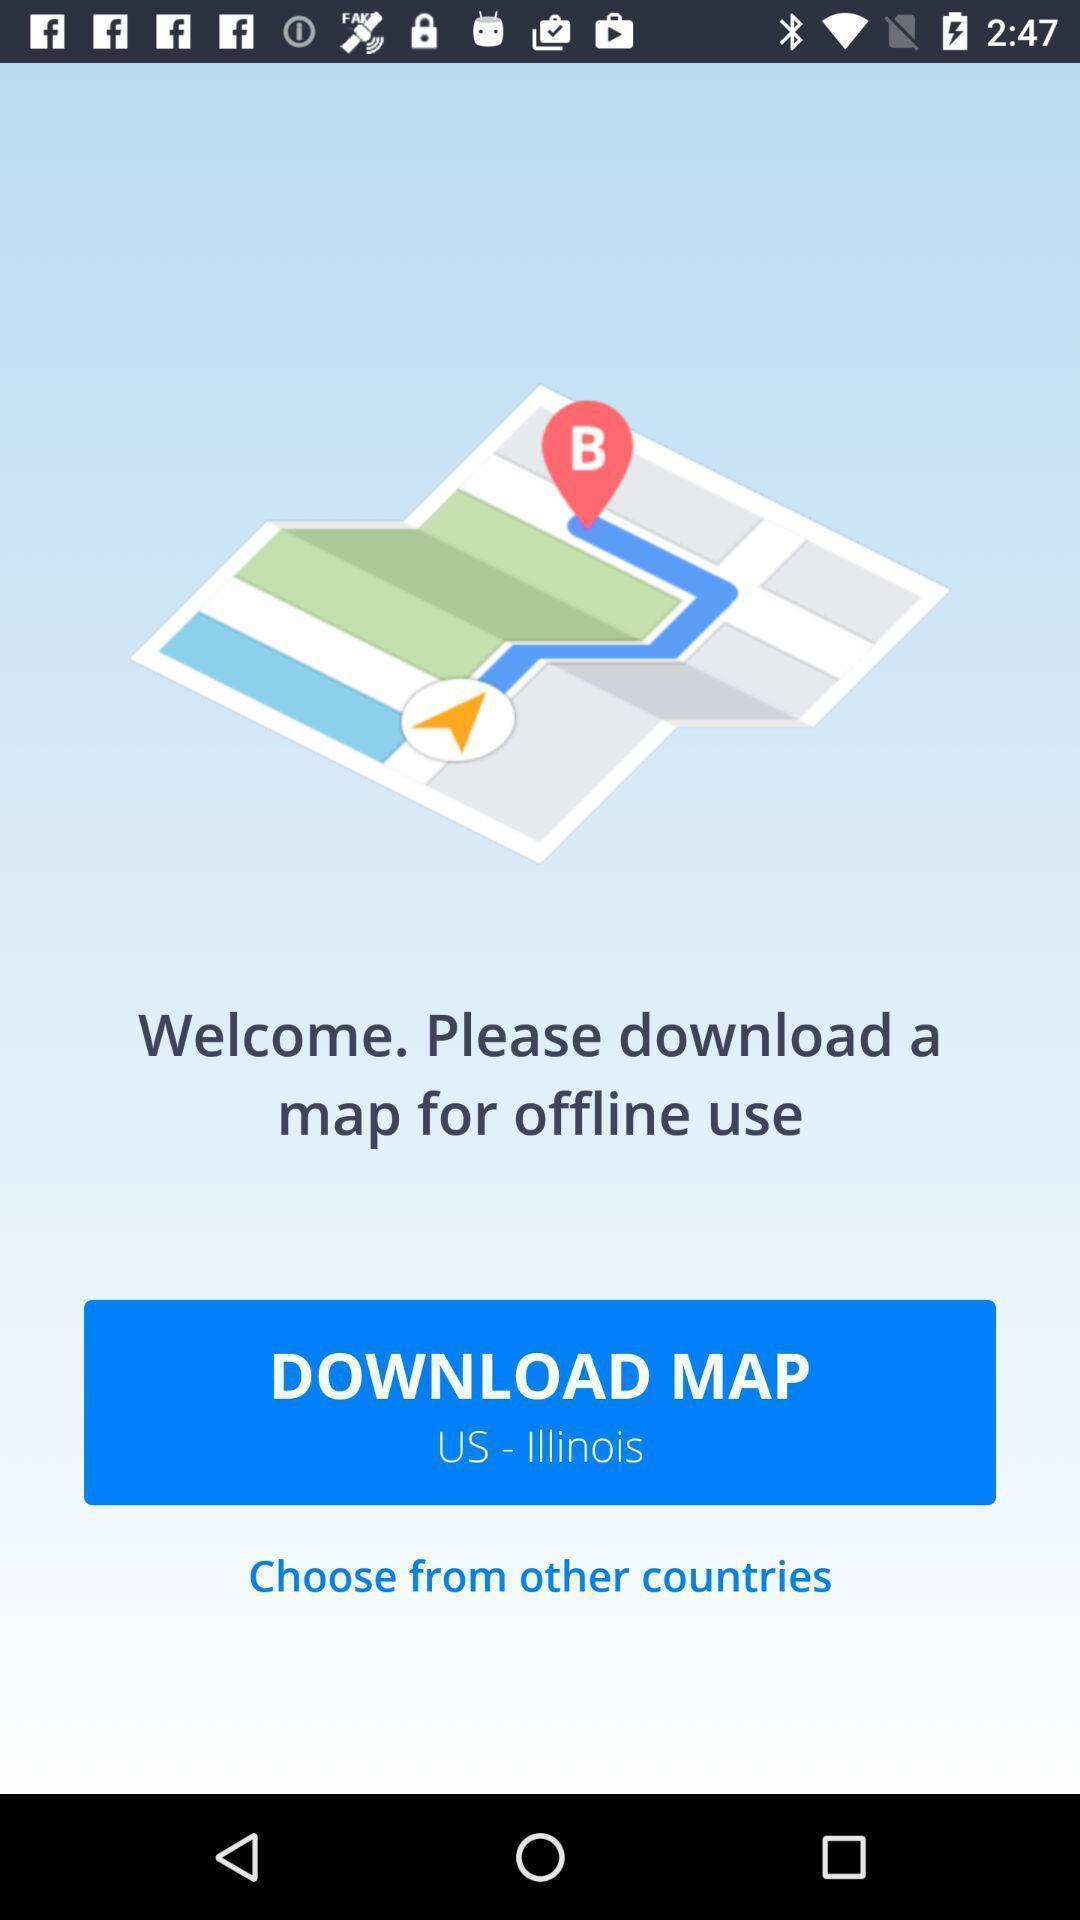Explain the elements present in this screenshot. Welcome page with download option. 